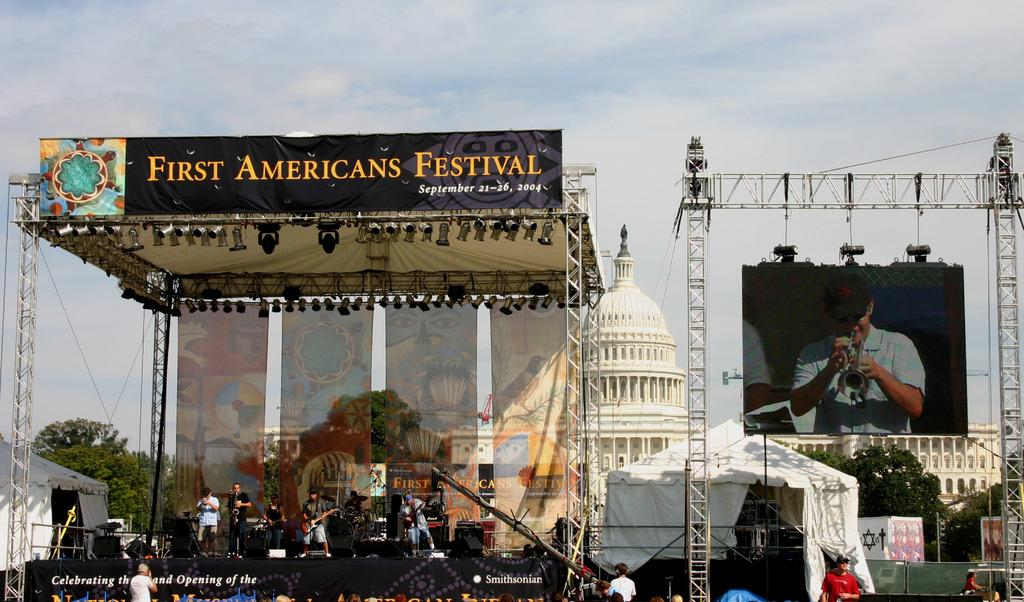<image>
Relay a brief, clear account of the picture shown. The stage at the First Americans Festival from 2004 with a projector image of the singer off to the side. 